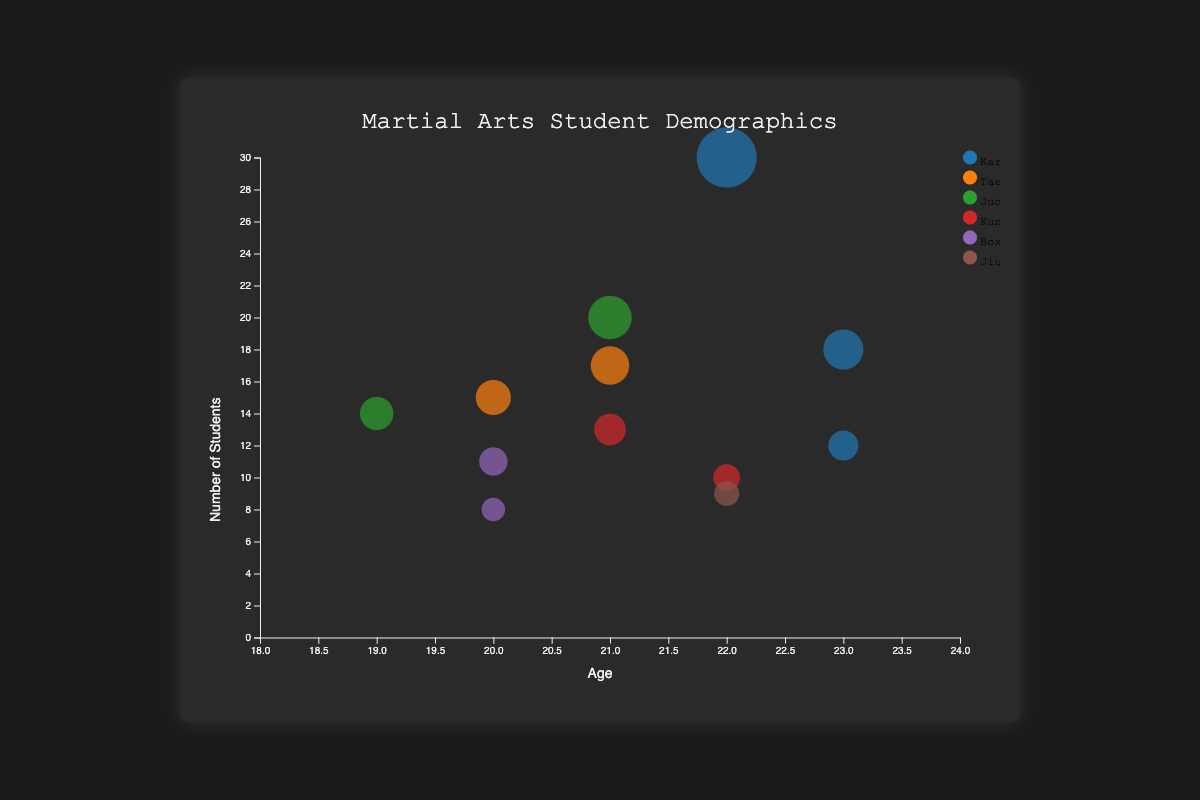What is the title of the chart? The title of the chart is displayed prominently at the top center of the chart, indicating the overall focus of the visualization.
Answer: Martial Arts Student Demographics What does the x-axis represent? The x-axis represents the age of martial arts students, which ranges from 18 to 24. This can be identified by the label at the bottom of the x-axis.
Answer: Age Which discipline has the largest number of students, and how many students are there? To find the largest number of students, look at the size of the bubbles and the number of students each bubble represents.
Answer: Karate (30 students) Which age group has the fewest male students, and in which disciplines are they enrolled? Examine the bubbles with the smallest radius for male students and check the ages associated with these bubbles. Then, identify which disciplines correspond to these data points.
Answer: Age 20, Boxing (8 students) What is the average number of students for all disciplines? Sum all the 'students_count' values and divide by the number of data points (12 in this case). Calculate the sum as 30 + 15 + 20 + 10 + 8 + 12 + 14 + 17 + 9 + 18 + 13 + 11 = 177, then divide by 12.
Answer: (30 + 15 + 20 + 10 + 8 + 12 + 14 + 17 + 9 + 18 + 13 + 11) / 12 = 14.75 How many students majoring in Computer Science are there, and how many disciplines do they choose? Identify the bubbles representing students majoring in Computer Science, add their 'students_count', and count the different disciplines they chose.
Answer: 42 students (Computer Science), 2 disciplines (Karate and Taekwondo) Which gender has more students in the discipline choice of Judo? Compare the 'students_count' for male and female bubbles associated with the Judo discipline. The chart will reveal the gender for each bubble.
Answer: Male (20 students) Which academic major has the highest participation in Karate, and what is the total number of students from this major? Look for the bubbles associated with the Karate discipline and check their 'academic_major' to find the highest participation. Sum the 'students_count' for this major.
Answer: Computer Science (30 + 12 = 42 students) Compare the number of Business Administration students in Taekwondo to those in Boxing. Identify the bubbles associated with Business Administration and the disciplines Taekwondo and Boxing, then compare their 'students_count'.
Answer: 15 (Taekwondo) vs. 8 (Boxing) In which academic major is the gender balance closest to equal, and what is the count for each gender? Find the academic major with the smallest difference between male and female 'students_count'. Check the bubbles related to each major and count the students by gender.
Answer: Mathematics (9 males, 18 females) 